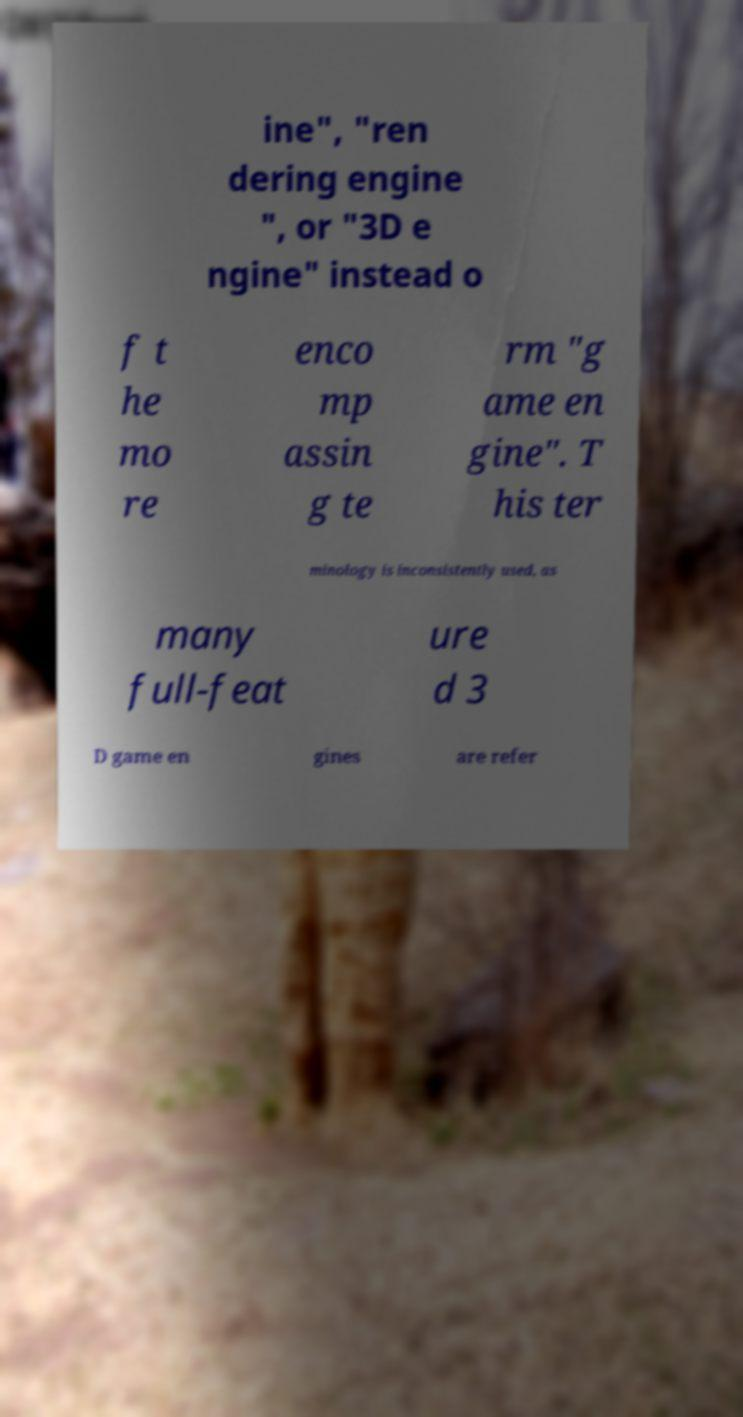Can you accurately transcribe the text from the provided image for me? ine", "ren dering engine ", or "3D e ngine" instead o f t he mo re enco mp assin g te rm "g ame en gine". T his ter minology is inconsistently used, as many full-feat ure d 3 D game en gines are refer 